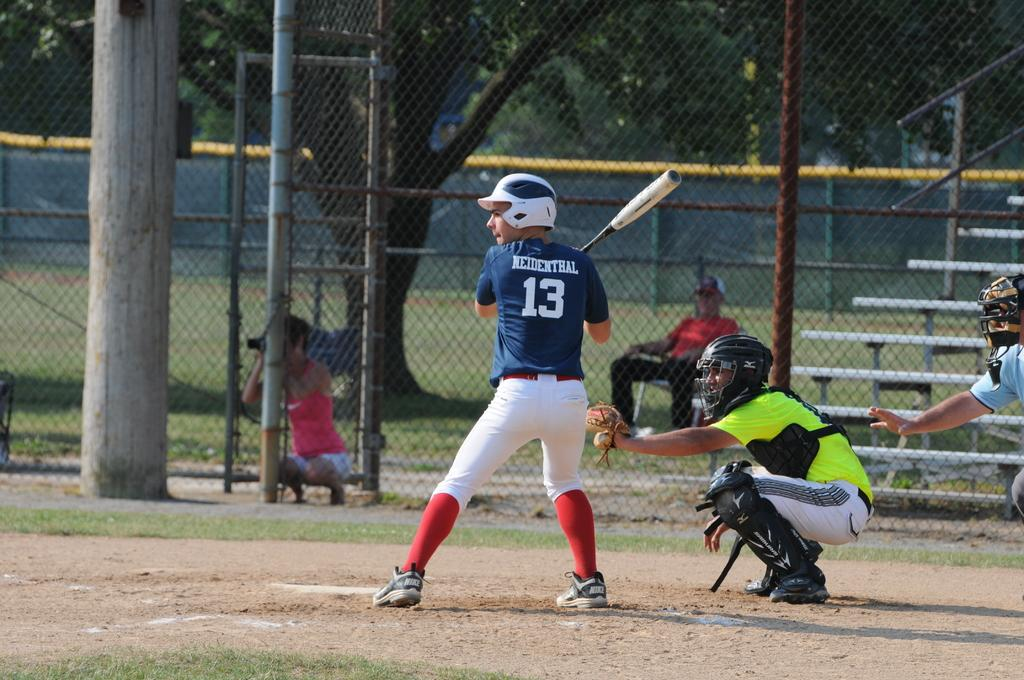<image>
Create a compact narrative representing the image presented. The baseball player with the number "13" on the back of his jersey is preparing to bat. 